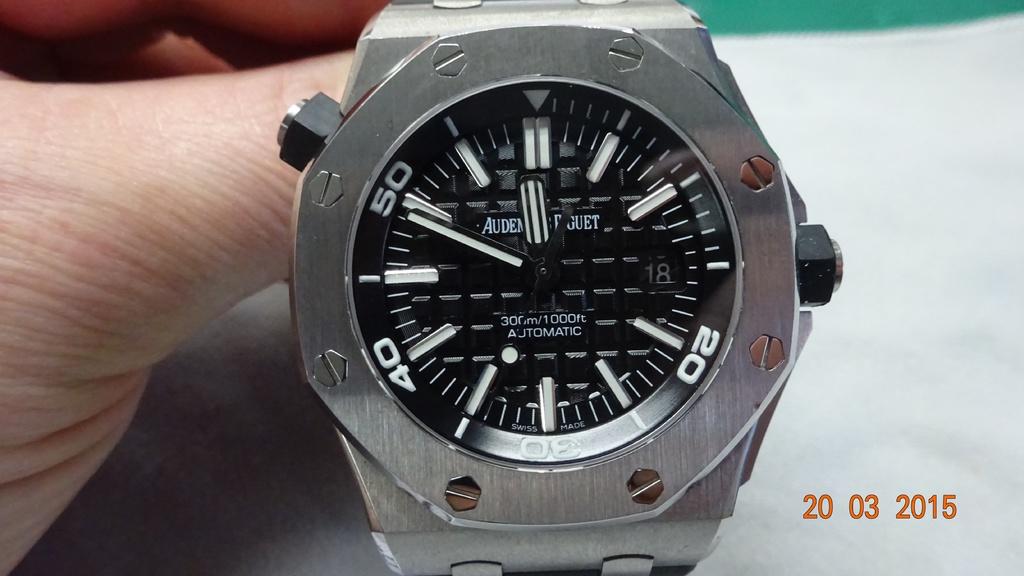What time is it?
Provide a succinct answer. 11:49. What number is the hand pointing to?
Give a very brief answer. 50. 